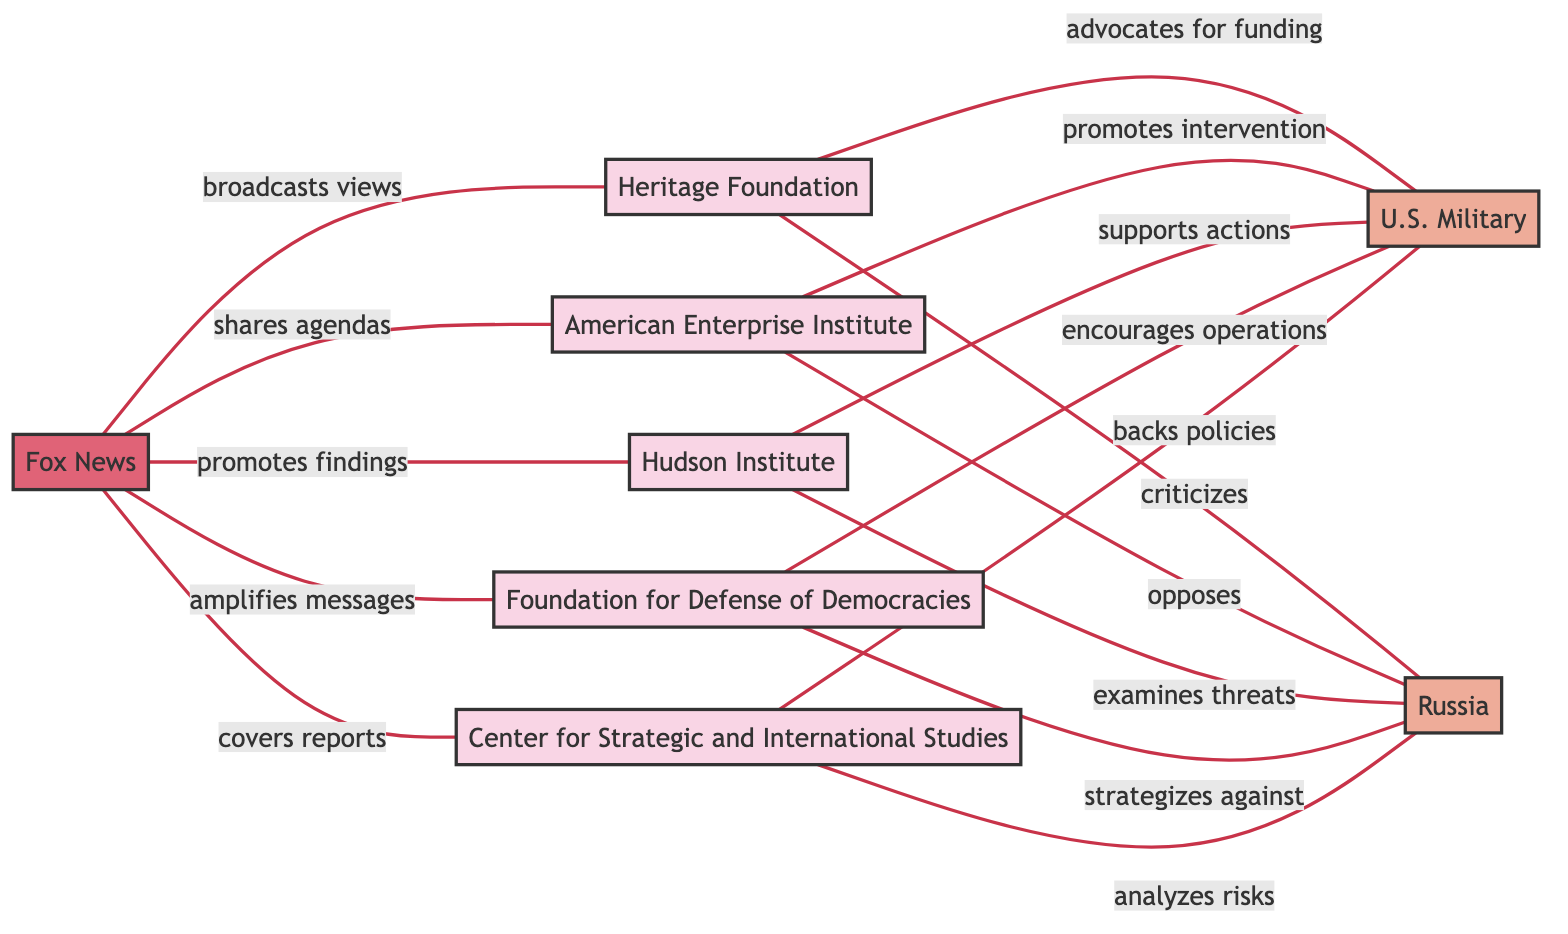What is the total number of think tanks represented in the diagram? There are five nodes classified as think tanks: Heritage Foundation, American Enterprise Institute, Hudson Institute, Foundation for Defense of Democracies, and Center for Strategic and International Studies. Therefore, the total number is 5.
Answer: 5 Which entity does the Heritage Foundation criticize? The link from the Heritage Foundation indicates it criticizes Russia, which is the target node connected by that relationship.
Answer: Russia What is the relationship between AEI and the U.S. Military? The AEI node shows a relationship labeled "promotes intervention" connected to the U.S. Military node. This indicates AEI advocates for military action, specifically promoting intervention.
Answer: promotes intervention Which think tank examines threats related to Russia? The Hudson Institute node is connected to Russia with a relationship labeled "examines threats," indicating that this think tank specifically investigates threats posed by Russia.
Answer: Hudson Institute How many connections does Fox News have to think tanks? Fox News has five connections, each linking to a different think tank: Heritage Foundation, AEI, Hudson Institute, FDD, and CSIS; therefore, it has a total of 5 connections.
Answer: 5 Which think tank encourages operations involving the U.S. Military? The link from the Foundation for Defense of Democracies indicates it encourages operations involving the U.S. Military, which shows its active support for military engagements.
Answer: Foundation for Defense of Democracies What is the reason Hudson Institute supports actions related to the U.S. Military? The Hudson Institute's relationship with the U.S. Military is described as "supports actions," which implies it backs specific military interventions or operations.
Answer: supports actions Which media outlet broadcasts views of the Heritage Foundation? The Fox News node is connected to the Heritage Foundation with the relationship labeled "broadcasts views," indicating it conveys or promotes the perspectives of the Heritage Foundation to its audience.
Answer: Fox News 